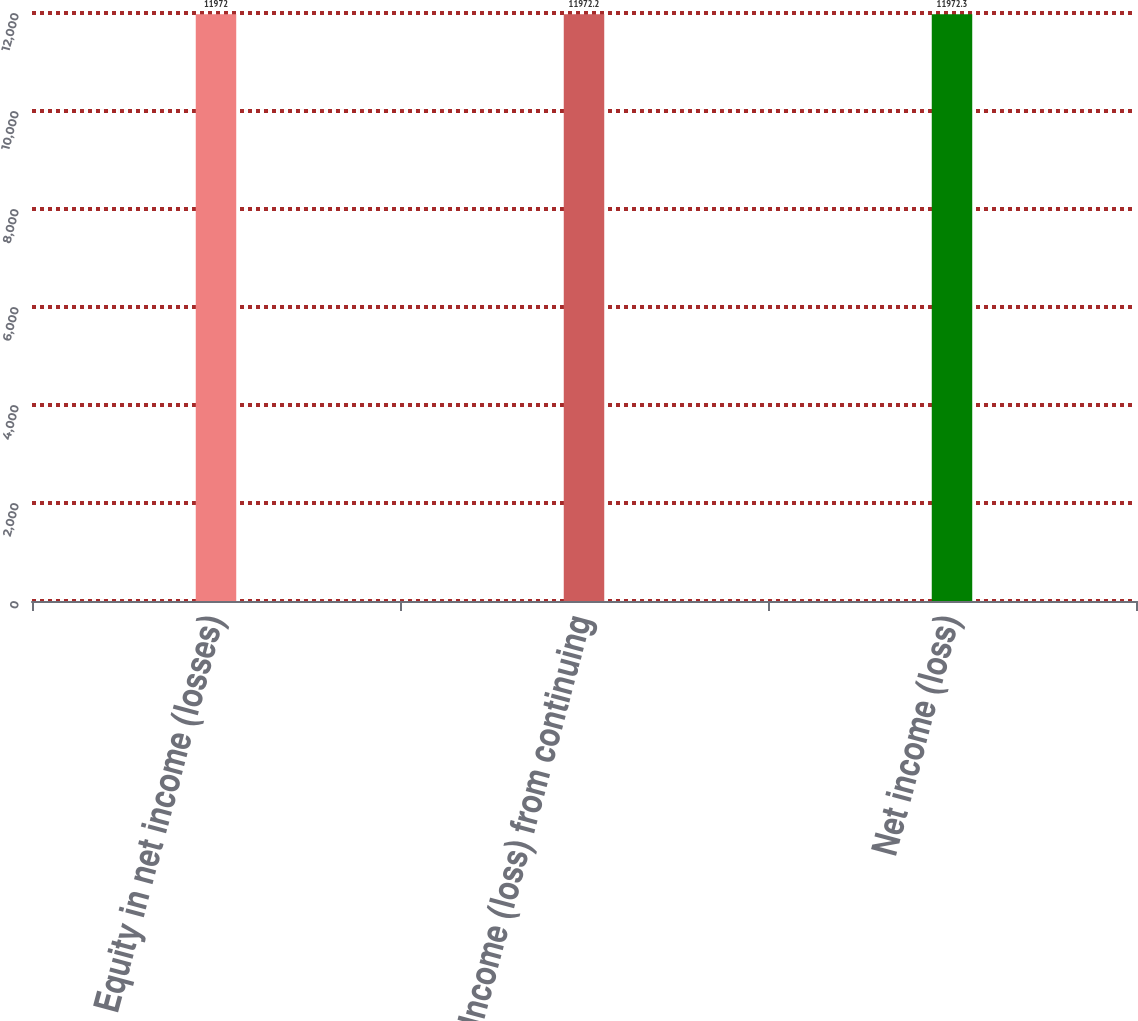Convert chart to OTSL. <chart><loc_0><loc_0><loc_500><loc_500><bar_chart><fcel>Equity in net income (losses)<fcel>Income (loss) from continuing<fcel>Net income (loss)<nl><fcel>11972<fcel>11972.2<fcel>11972.3<nl></chart> 